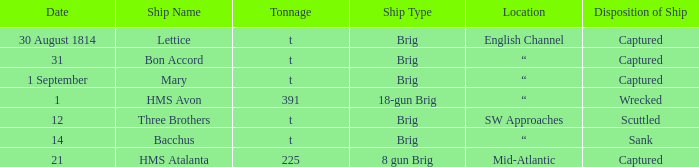For the ship that was a brig and located in the English Channel, what was the disposition of ship? Captured. 